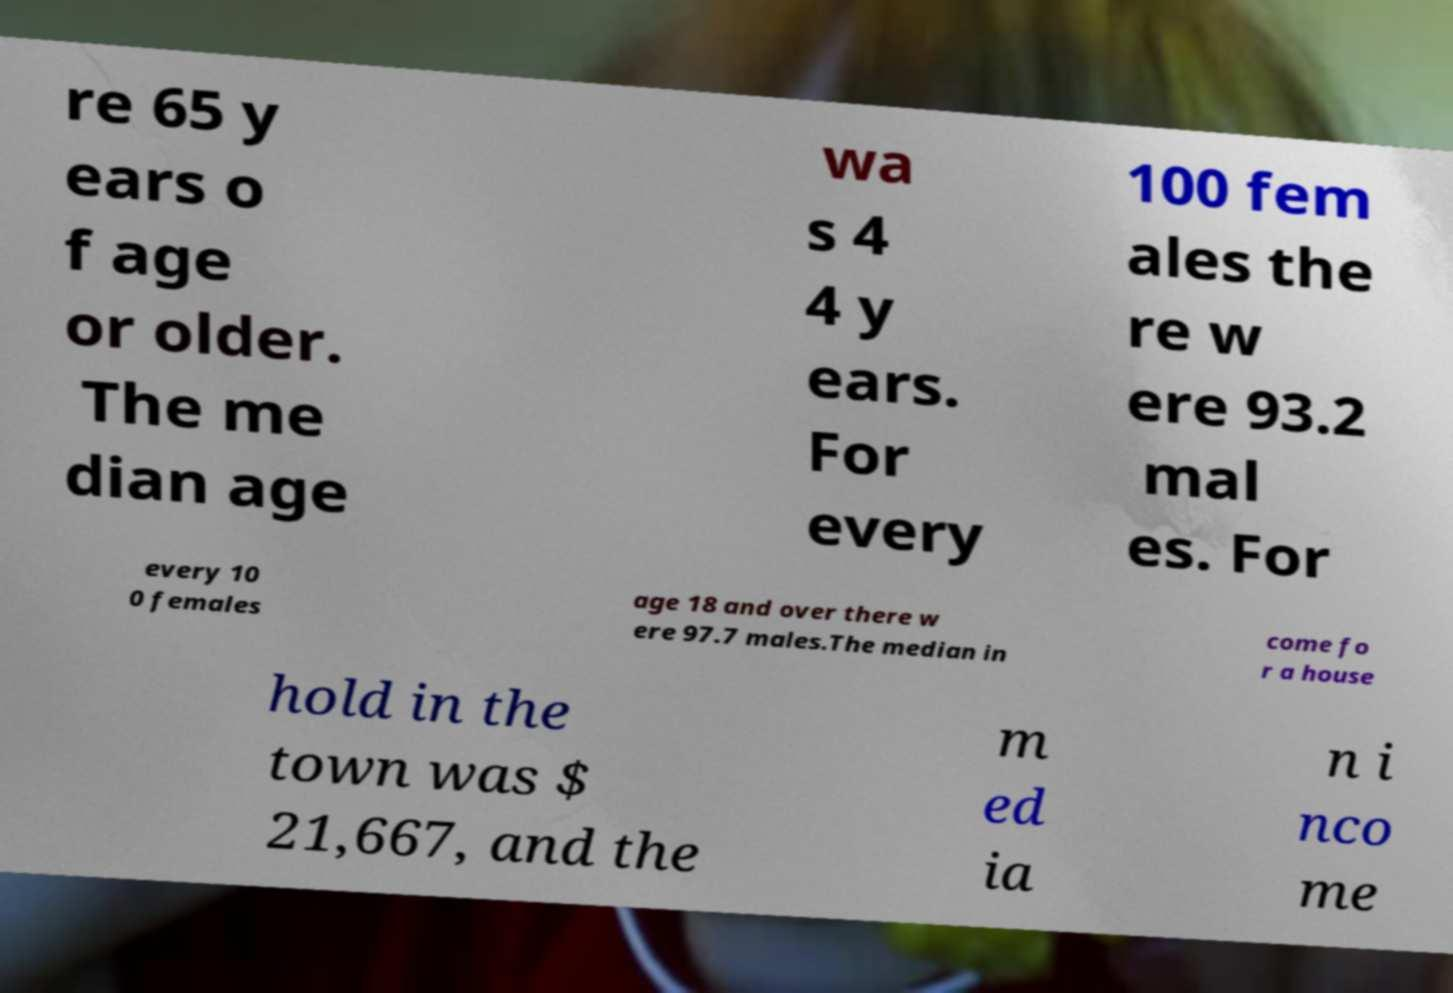What messages or text are displayed in this image? I need them in a readable, typed format. re 65 y ears o f age or older. The me dian age wa s 4 4 y ears. For every 100 fem ales the re w ere 93.2 mal es. For every 10 0 females age 18 and over there w ere 97.7 males.The median in come fo r a house hold in the town was $ 21,667, and the m ed ia n i nco me 